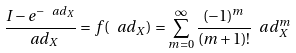Convert formula to latex. <formula><loc_0><loc_0><loc_500><loc_500>\frac { I - e ^ { - \ a d _ { X } } } { \ a d _ { X } } = f ( \ a d _ { X } ) = \sum _ { m = 0 } ^ { \infty } \frac { ( - 1 ) ^ { m } } { ( m + 1 ) ! } \ a d _ { X } ^ { m }</formula> 